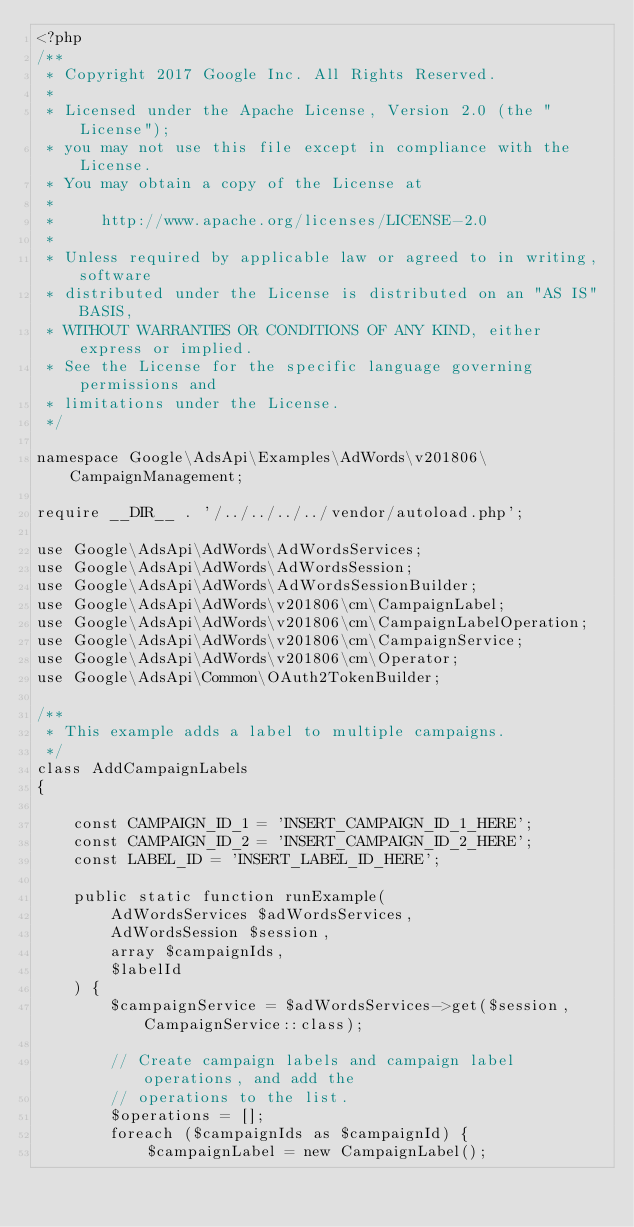<code> <loc_0><loc_0><loc_500><loc_500><_PHP_><?php
/**
 * Copyright 2017 Google Inc. All Rights Reserved.
 *
 * Licensed under the Apache License, Version 2.0 (the "License");
 * you may not use this file except in compliance with the License.
 * You may obtain a copy of the License at
 *
 *     http://www.apache.org/licenses/LICENSE-2.0
 *
 * Unless required by applicable law or agreed to in writing, software
 * distributed under the License is distributed on an "AS IS" BASIS,
 * WITHOUT WARRANTIES OR CONDITIONS OF ANY KIND, either express or implied.
 * See the License for the specific language governing permissions and
 * limitations under the License.
 */

namespace Google\AdsApi\Examples\AdWords\v201806\CampaignManagement;

require __DIR__ . '/../../../../vendor/autoload.php';

use Google\AdsApi\AdWords\AdWordsServices;
use Google\AdsApi\AdWords\AdWordsSession;
use Google\AdsApi\AdWords\AdWordsSessionBuilder;
use Google\AdsApi\AdWords\v201806\cm\CampaignLabel;
use Google\AdsApi\AdWords\v201806\cm\CampaignLabelOperation;
use Google\AdsApi\AdWords\v201806\cm\CampaignService;
use Google\AdsApi\AdWords\v201806\cm\Operator;
use Google\AdsApi\Common\OAuth2TokenBuilder;

/**
 * This example adds a label to multiple campaigns.
 */
class AddCampaignLabels
{

    const CAMPAIGN_ID_1 = 'INSERT_CAMPAIGN_ID_1_HERE';
    const CAMPAIGN_ID_2 = 'INSERT_CAMPAIGN_ID_2_HERE';
    const LABEL_ID = 'INSERT_LABEL_ID_HERE';

    public static function runExample(
        AdWordsServices $adWordsServices,
        AdWordsSession $session,
        array $campaignIds,
        $labelId
    ) {
        $campaignService = $adWordsServices->get($session, CampaignService::class);

        // Create campaign labels and campaign label operations, and add the
        // operations to the list.
        $operations = [];
        foreach ($campaignIds as $campaignId) {
            $campaignLabel = new CampaignLabel();</code> 